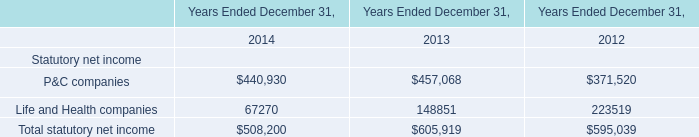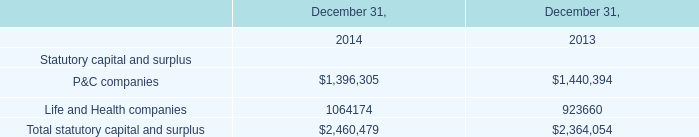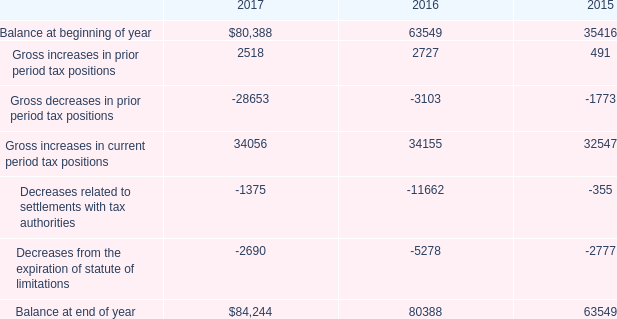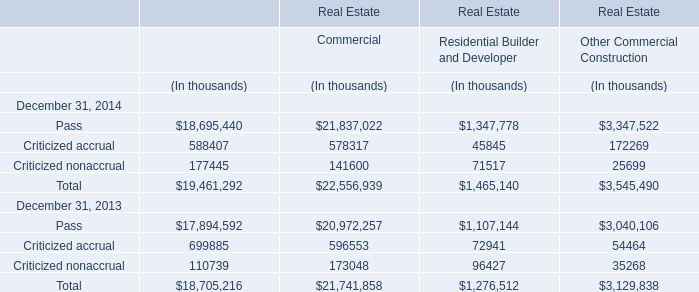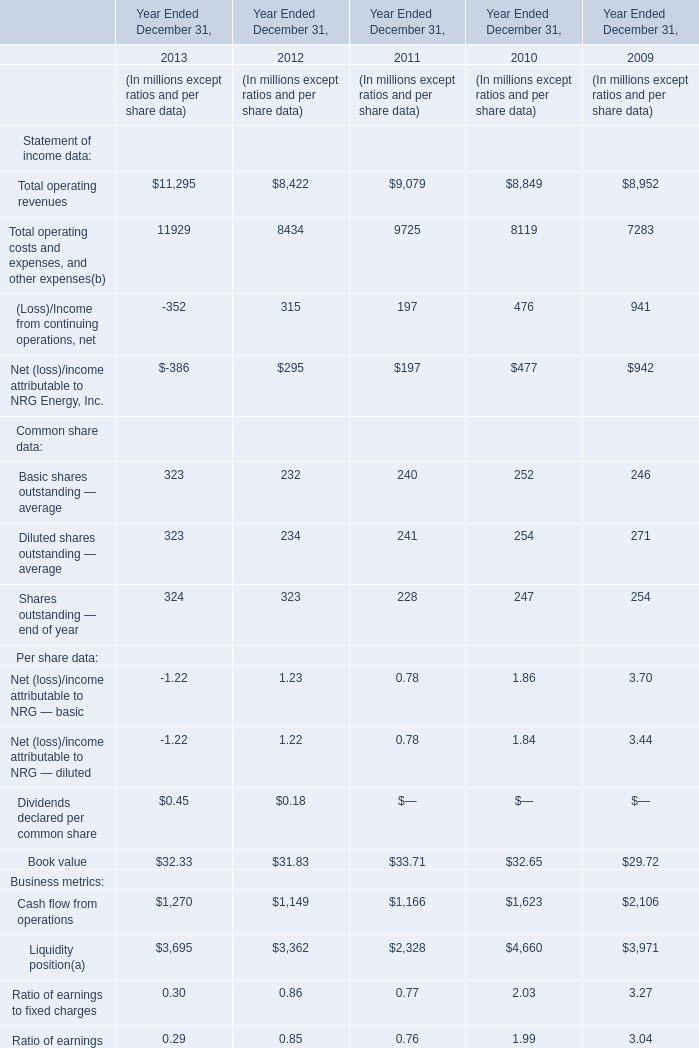What's the sum of Decreases from the expiration of statute of limitations of 2015, and Life and Health companies of Years Ended December 31, 2013 ? 
Computations: (2777.0 + 148851.0)
Answer: 151628.0. 